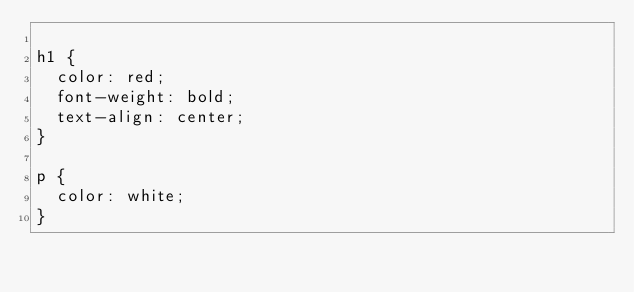Convert code to text. <code><loc_0><loc_0><loc_500><loc_500><_CSS_>
h1 {
	color: red;
	font-weight: bold;
	text-align: center;
}

p {
	color: white;
}</code> 